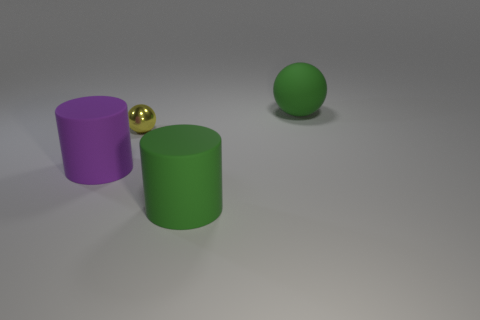Add 1 big purple matte balls. How many objects exist? 5 Subtract 0 purple spheres. How many objects are left? 4 Subtract all red matte balls. Subtract all big purple rubber cylinders. How many objects are left? 3 Add 3 big cylinders. How many big cylinders are left? 5 Add 4 small purple matte objects. How many small purple matte objects exist? 4 